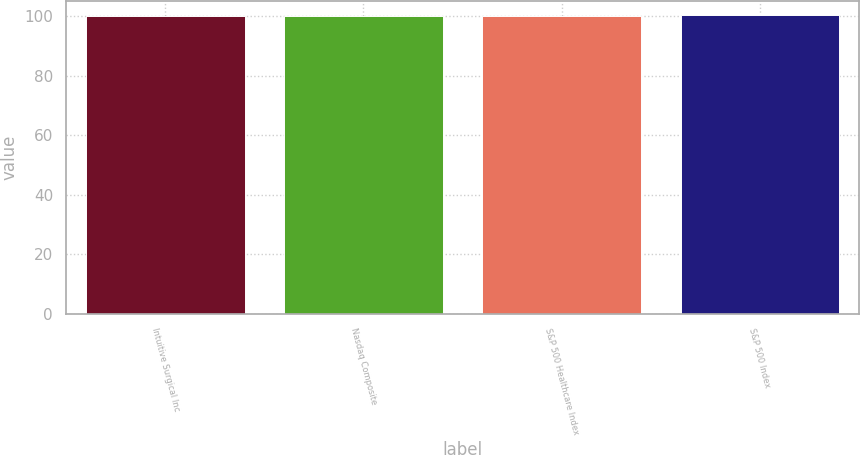Convert chart to OTSL. <chart><loc_0><loc_0><loc_500><loc_500><bar_chart><fcel>Intuitive Surgical Inc<fcel>Nasdaq Composite<fcel>S&P 500 Healthcare Index<fcel>S&P 500 Index<nl><fcel>100<fcel>100.1<fcel>100.2<fcel>100.3<nl></chart> 